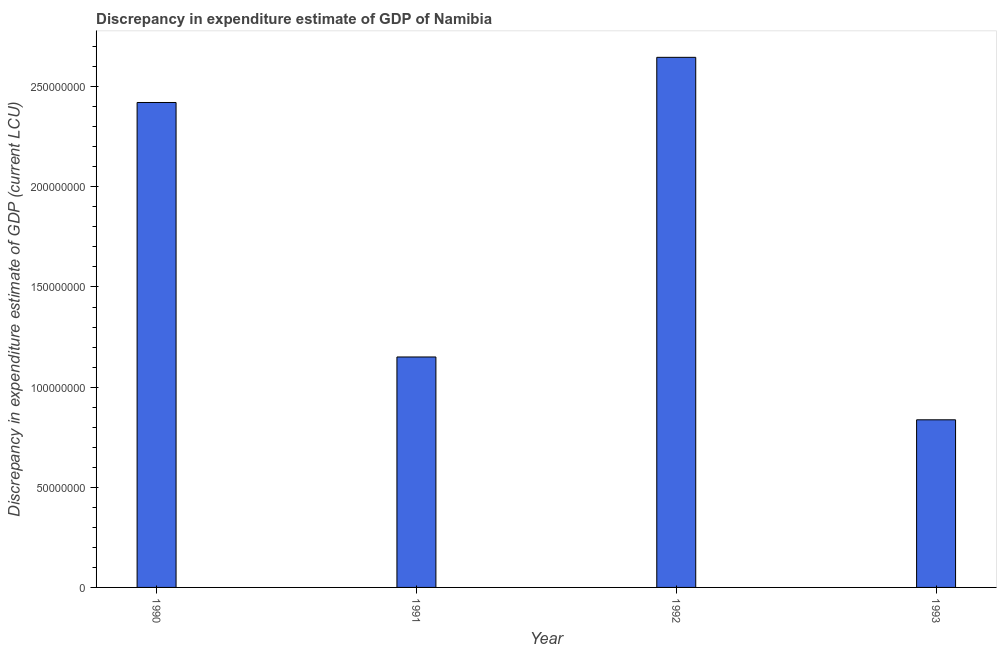Does the graph contain any zero values?
Offer a terse response. No. Does the graph contain grids?
Your answer should be very brief. No. What is the title of the graph?
Give a very brief answer. Discrepancy in expenditure estimate of GDP of Namibia. What is the label or title of the X-axis?
Your answer should be very brief. Year. What is the label or title of the Y-axis?
Your answer should be very brief. Discrepancy in expenditure estimate of GDP (current LCU). What is the discrepancy in expenditure estimate of gdp in 1991?
Offer a terse response. 1.15e+08. Across all years, what is the maximum discrepancy in expenditure estimate of gdp?
Your answer should be very brief. 2.65e+08. Across all years, what is the minimum discrepancy in expenditure estimate of gdp?
Ensure brevity in your answer.  8.37e+07. In which year was the discrepancy in expenditure estimate of gdp maximum?
Your answer should be very brief. 1992. What is the sum of the discrepancy in expenditure estimate of gdp?
Provide a short and direct response. 7.06e+08. What is the difference between the discrepancy in expenditure estimate of gdp in 1992 and 1993?
Your response must be concise. 1.81e+08. What is the average discrepancy in expenditure estimate of gdp per year?
Make the answer very short. 1.76e+08. What is the median discrepancy in expenditure estimate of gdp?
Your answer should be very brief. 1.79e+08. What is the ratio of the discrepancy in expenditure estimate of gdp in 1991 to that in 1992?
Offer a very short reply. 0.43. Is the difference between the discrepancy in expenditure estimate of gdp in 1990 and 1992 greater than the difference between any two years?
Your answer should be very brief. No. What is the difference between the highest and the second highest discrepancy in expenditure estimate of gdp?
Your answer should be compact. 2.26e+07. What is the difference between the highest and the lowest discrepancy in expenditure estimate of gdp?
Provide a short and direct response. 1.81e+08. In how many years, is the discrepancy in expenditure estimate of gdp greater than the average discrepancy in expenditure estimate of gdp taken over all years?
Provide a succinct answer. 2. How many bars are there?
Your answer should be compact. 4. Are all the bars in the graph horizontal?
Your answer should be very brief. No. Are the values on the major ticks of Y-axis written in scientific E-notation?
Ensure brevity in your answer.  No. What is the Discrepancy in expenditure estimate of GDP (current LCU) in 1990?
Ensure brevity in your answer.  2.42e+08. What is the Discrepancy in expenditure estimate of GDP (current LCU) of 1991?
Make the answer very short. 1.15e+08. What is the Discrepancy in expenditure estimate of GDP (current LCU) of 1992?
Your response must be concise. 2.65e+08. What is the Discrepancy in expenditure estimate of GDP (current LCU) in 1993?
Ensure brevity in your answer.  8.37e+07. What is the difference between the Discrepancy in expenditure estimate of GDP (current LCU) in 1990 and 1991?
Keep it short and to the point. 1.27e+08. What is the difference between the Discrepancy in expenditure estimate of GDP (current LCU) in 1990 and 1992?
Keep it short and to the point. -2.26e+07. What is the difference between the Discrepancy in expenditure estimate of GDP (current LCU) in 1990 and 1993?
Your answer should be very brief. 1.58e+08. What is the difference between the Discrepancy in expenditure estimate of GDP (current LCU) in 1991 and 1992?
Make the answer very short. -1.50e+08. What is the difference between the Discrepancy in expenditure estimate of GDP (current LCU) in 1991 and 1993?
Your answer should be very brief. 3.14e+07. What is the difference between the Discrepancy in expenditure estimate of GDP (current LCU) in 1992 and 1993?
Offer a very short reply. 1.81e+08. What is the ratio of the Discrepancy in expenditure estimate of GDP (current LCU) in 1990 to that in 1991?
Your answer should be very brief. 2.1. What is the ratio of the Discrepancy in expenditure estimate of GDP (current LCU) in 1990 to that in 1992?
Make the answer very short. 0.92. What is the ratio of the Discrepancy in expenditure estimate of GDP (current LCU) in 1990 to that in 1993?
Ensure brevity in your answer.  2.89. What is the ratio of the Discrepancy in expenditure estimate of GDP (current LCU) in 1991 to that in 1992?
Make the answer very short. 0.43. What is the ratio of the Discrepancy in expenditure estimate of GDP (current LCU) in 1991 to that in 1993?
Offer a very short reply. 1.38. What is the ratio of the Discrepancy in expenditure estimate of GDP (current LCU) in 1992 to that in 1993?
Offer a very short reply. 3.16. 